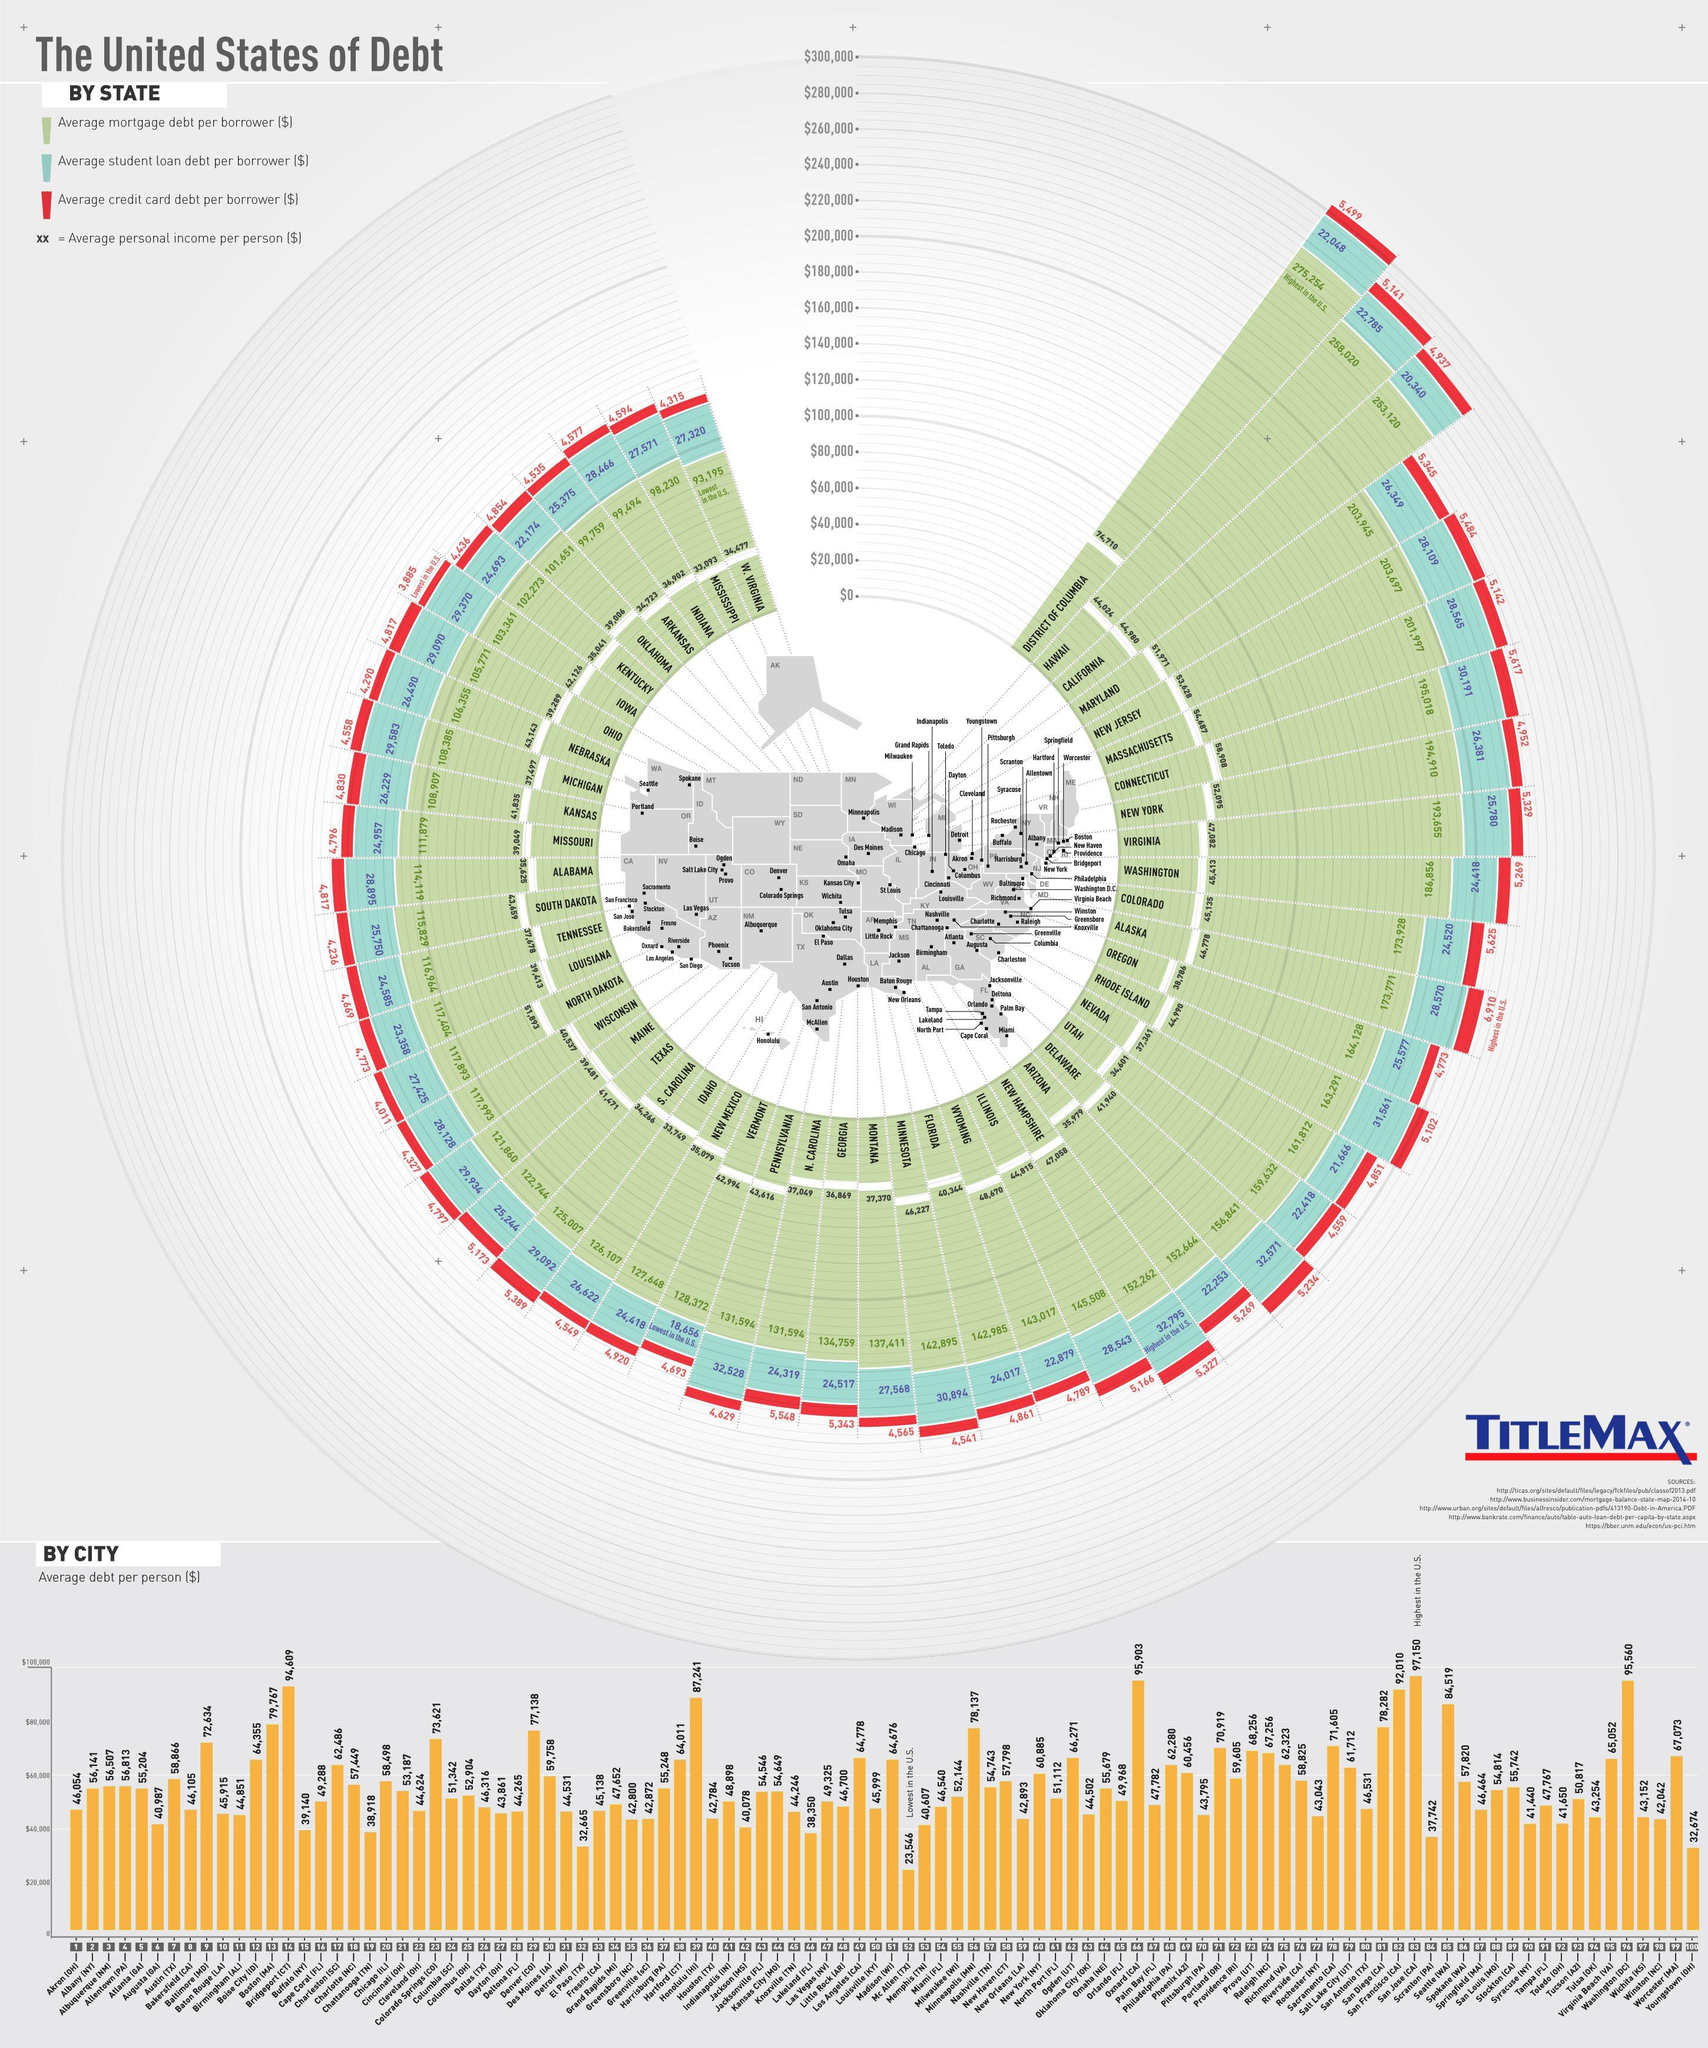Indicate a few pertinent items in this graphic. The average credit card debt per borrower in New Jersey is approximately $5,484. The average student loan debt per borrower in Florida is approximately $24,017. The average mortgage debt per borrower in Iowa is 103,361. The average mortgage debt per borrower in Texas is $122,744. The average credit card debt per borrower in Maine is approximately $4,797. 